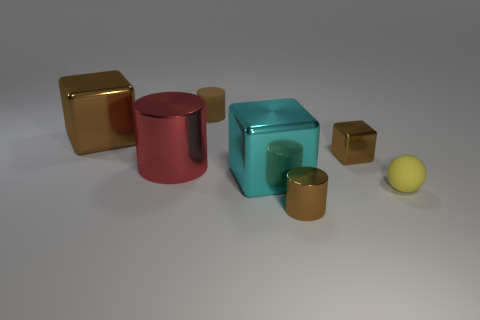Subtract all gray cylinders. How many brown cubes are left? 2 Subtract 1 cubes. How many cubes are left? 2 Subtract all large blocks. How many blocks are left? 1 Add 3 large red rubber objects. How many objects exist? 10 Subtract 0 cyan cylinders. How many objects are left? 7 Subtract all spheres. How many objects are left? 6 Subtract all big gray cylinders. Subtract all small brown metal blocks. How many objects are left? 6 Add 1 tiny brown metallic objects. How many tiny brown metallic objects are left? 3 Add 7 red cylinders. How many red cylinders exist? 8 